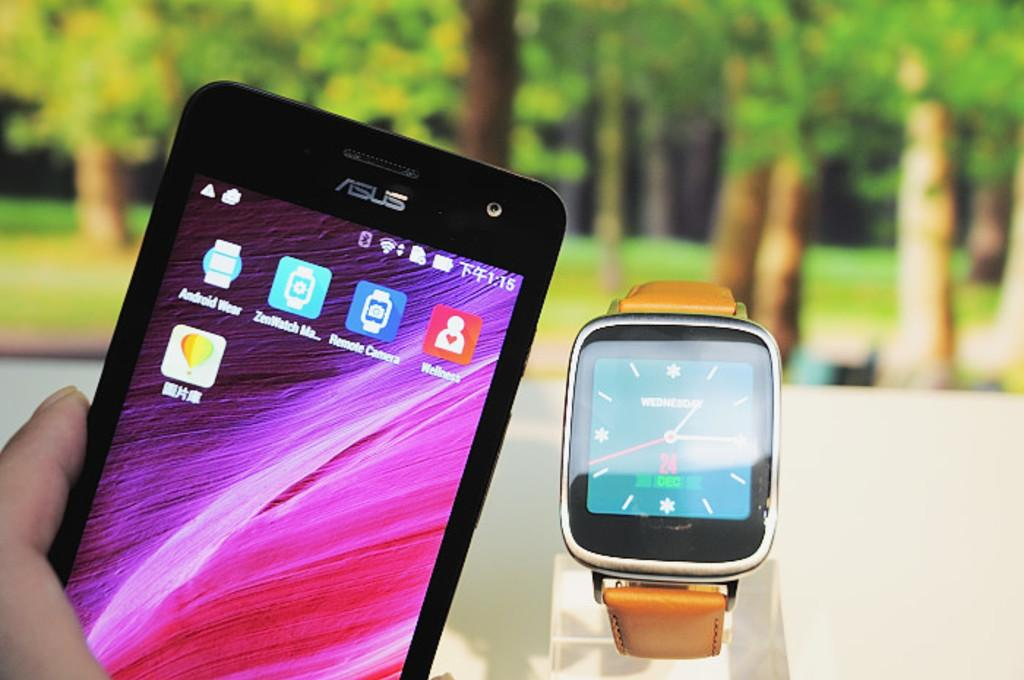<image>
Write a terse but informative summary of the picture. a phone that says 1:15 in the top right 